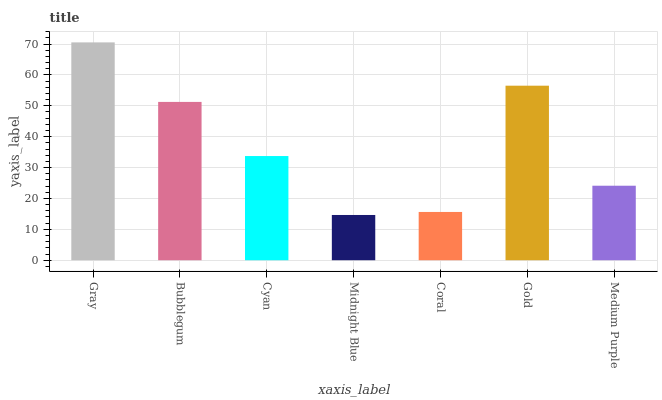Is Midnight Blue the minimum?
Answer yes or no. Yes. Is Gray the maximum?
Answer yes or no. Yes. Is Bubblegum the minimum?
Answer yes or no. No. Is Bubblegum the maximum?
Answer yes or no. No. Is Gray greater than Bubblegum?
Answer yes or no. Yes. Is Bubblegum less than Gray?
Answer yes or no. Yes. Is Bubblegum greater than Gray?
Answer yes or no. No. Is Gray less than Bubblegum?
Answer yes or no. No. Is Cyan the high median?
Answer yes or no. Yes. Is Cyan the low median?
Answer yes or no. Yes. Is Bubblegum the high median?
Answer yes or no. No. Is Bubblegum the low median?
Answer yes or no. No. 